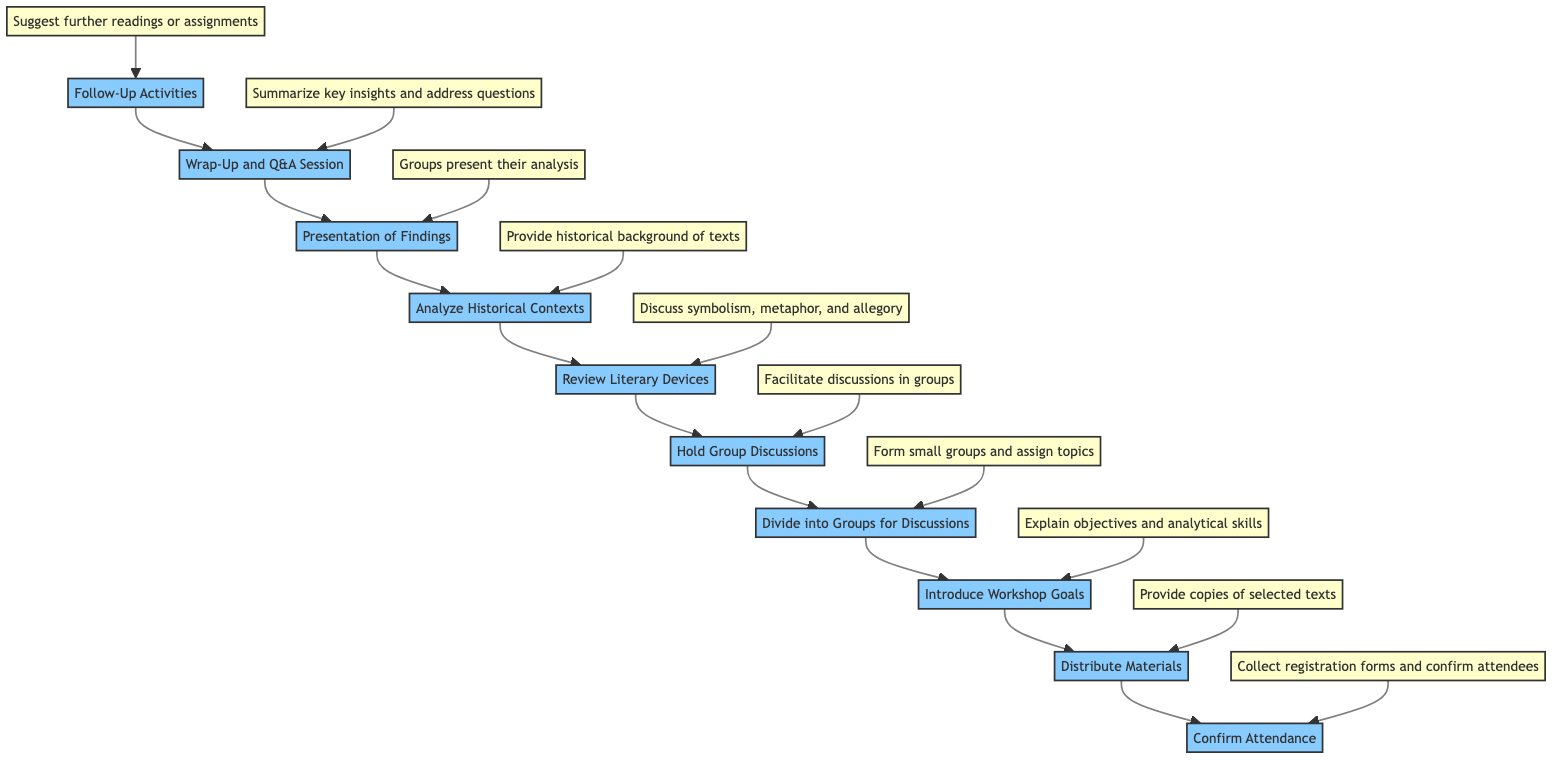What is the first step in the workshop organization? The first step in the flowchart, situated at the bottom, is "Confirm Attendance," which indicates the initial action to take.
Answer: Confirm Attendance How many total steps are outlined in the diagram? By counting the nodes in the flowchart from bottom to top, there are ten distinct steps involved in organizing the literary analysis workshop.
Answer: Ten What follows after the "Analyze Historical Contexts" step? Looking at the flowchart, the next step that follows "Analyze Historical Contexts" is "Presentation of Findings," indicating the order of activities in the workshop.
Answer: Presentation of Findings What is discussed during the "Review Literary Devices" step? The diagram specifies that in the "Review Literary Devices" step, various literary devices such as symbolism, metaphor, and allegory are discussed.
Answer: Symbolism, metaphor, and allegory What is the purpose of the "Wrap-Up and Q&A Session"? The "Wrap-Up and Q&A Session" is meant to summarize key insights and provide an opportunity for addressing participants' questions and feedback, thus clarifying its purpose.
Answer: Summarize key insights and address questions If a participant misses the "Distribute Materials" step, which workshop element could be affected? If the "Distribute Materials" step is overlooked, participants may not receive the necessary copies of selected texts, indicating a direct impact on the materials they need for analysis.
Answer: Copies of selected texts What is the relationship between "Hold Group Discussions" and "Divide into Groups for Discussions"? "Hold Group Discussions" follows directly after "Divide into Groups for Discussions," signifying that discussions can only occur once groups have been formed, establishing a sequential relationship between these two steps.
Answer: Sequential relationship Which step involves providing further reading suggestions? The last step in the flowchart is "Follow-Up Activities," which is where further reading suggestions or assignments are proposed to participants for deeper engagement post-workshop.
Answer: Follow-Up Activities What is a common theme addressed in the workshop? The workshop addresses themes that are related to character analysis, as highlighted in the "Divide into Groups for Discussions" step, suggesting a recurring focus on character analysis.
Answer: Character analysis 